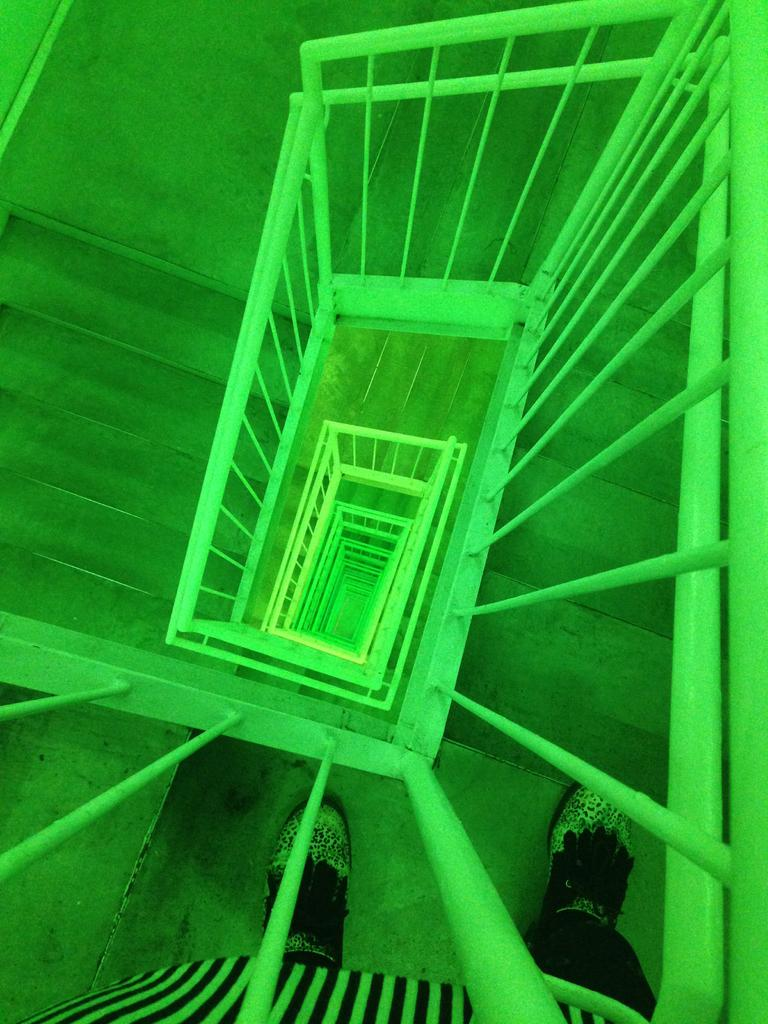What is the main subject of the image? There is a person standing in the image. What architectural feature can be seen in the image? There are steps in the image. What type of barrier is present in the image? There is a fence in the image. What type of brake is being used by the person in the image? There is no brake present in the image, as it features a person standing near steps and a fence. 